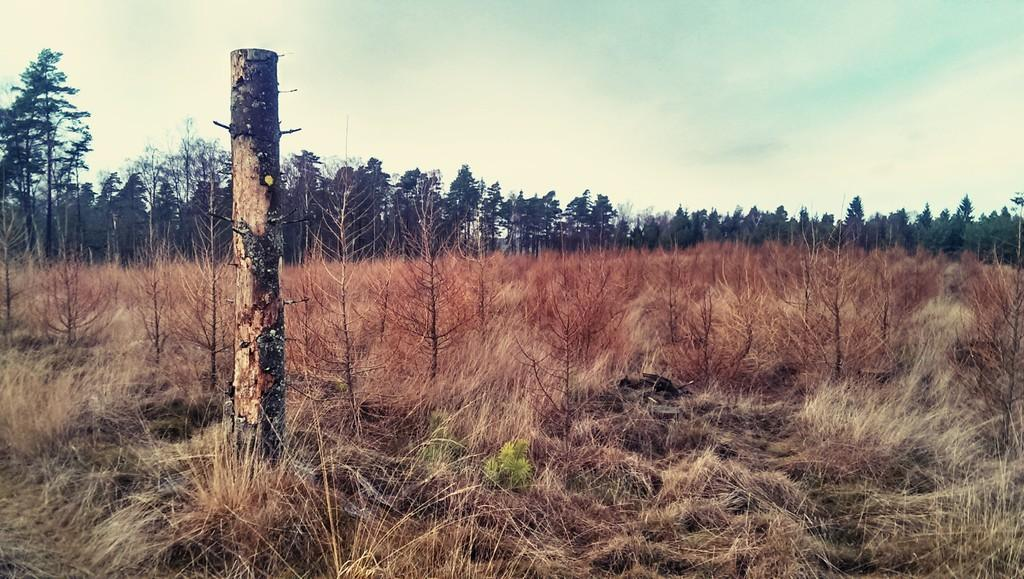What type of vegetation is present at the bottom of the image? There is grass and bare plants at the bottom of the image. What can be seen on the left side of the image? There is a wooden pole on the left side of the image. What is visible in the background of the image? There are trees and clouds in the sky in the background of the image. How many brothers are depicted in the image? There are no brothers present in the image. Can you describe the face of the passenger in the image? There is no passenger or face present in the image. 